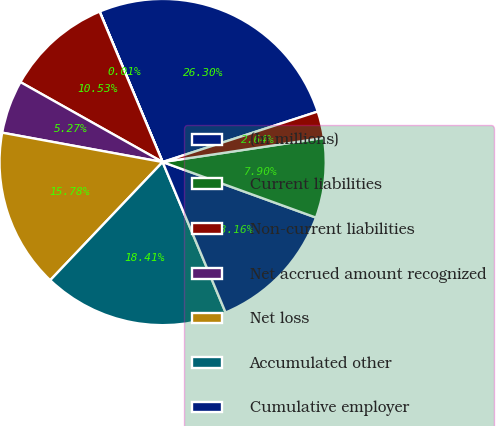Convert chart. <chart><loc_0><loc_0><loc_500><loc_500><pie_chart><fcel>(In millions)<fcel>Current liabilities<fcel>Non-current liabilities<fcel>Net accrued amount recognized<fcel>Net loss<fcel>Accumulated other<fcel>Cumulative employer<fcel>Net obligation recognized in<fcel>Discount rate<nl><fcel>26.3%<fcel>0.01%<fcel>10.53%<fcel>5.27%<fcel>15.78%<fcel>18.41%<fcel>13.16%<fcel>7.9%<fcel>2.64%<nl></chart> 